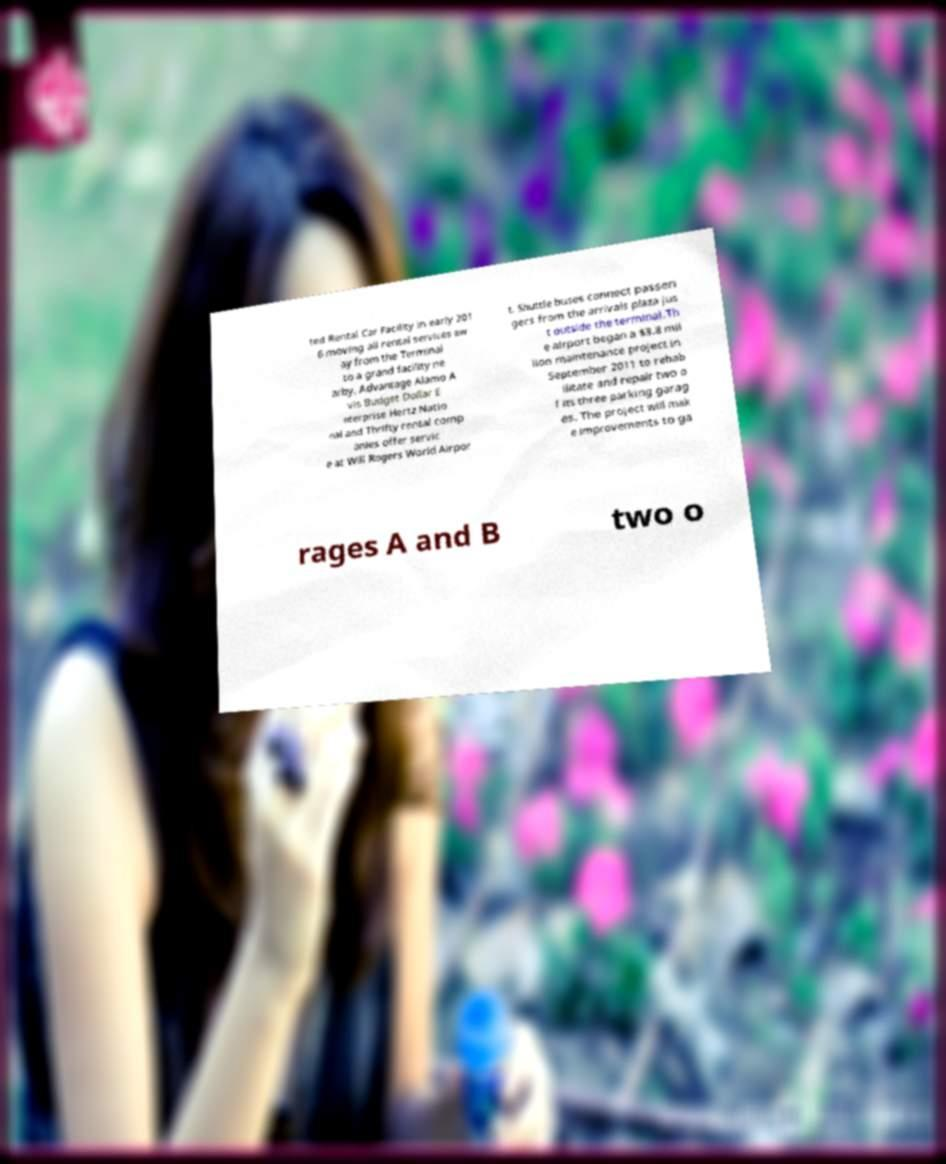Please read and relay the text visible in this image. What does it say? ted Rental Car Facility in early 201 6 moving all rental services aw ay from the Terminal to a grand facility ne arby. Advantage Alamo A vis Budget Dollar E nterprise Hertz Natio nal and Thrifty rental comp anies offer servic e at Will Rogers World Airpor t. Shuttle buses connect passen gers from the arrivals plaza jus t outside the terminal.Th e airport began a $3.8 mil lion maintenance project in September 2011 to rehab ilitate and repair two o f its three parking garag es. The project will mak e improvements to ga rages A and B two o 